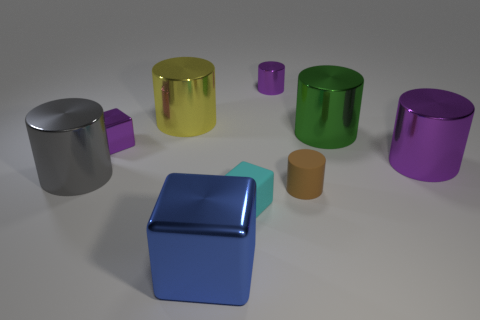How many large things are gray shiny cylinders or shiny cylinders?
Offer a very short reply. 4. How many purple cubes are the same material as the small brown object?
Keep it short and to the point. 0. There is a purple metallic thing to the left of the small cyan rubber object; what is its size?
Provide a short and direct response. Small. What shape is the purple object that is left of the metal thing in front of the gray thing?
Provide a short and direct response. Cube. There is a tiny thing left of the large metal thing that is in front of the big gray object; what number of tiny cyan cubes are to the left of it?
Your answer should be very brief. 0. Are there fewer tiny purple shiny blocks behind the purple shiny cube than small purple blocks?
Ensure brevity in your answer.  Yes. Is there anything else that is the same shape as the cyan matte thing?
Your answer should be very brief. Yes. There is a small purple shiny thing on the right side of the small cyan thing; what shape is it?
Your answer should be very brief. Cylinder. What shape is the big blue object that is in front of the shiny block behind the small cube that is to the right of the yellow thing?
Your answer should be very brief. Cube. What number of objects are large green shiny things or small metal things?
Your answer should be compact. 3. 